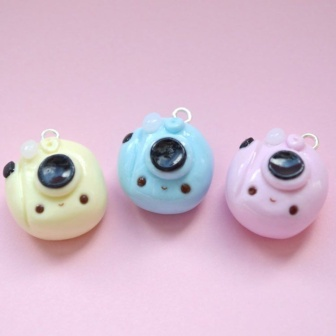Can you describe the overall aesthetic of this image? The overall aesthetic of the image is cute and whimsical, characterized by soft pastel hues that create a soothing and harmonious visual experience. The charms' round faces, petite size, and innocent expressions contribute to a sense of playfulness and delight. The pink background complements the pastel colors of the charms, enhancing the image's overall gentle and charming vibe. What do you think these cute bird-shaped charms could be used for? These bird-shaped charms could have a variety of uses. They might be used as keychains to add a touch of cuteness to one's keys, or as decorative elements on bags and backpacks. Given their charming design, they could also serve as delightful additions to a nursery mobile, a whimsical phone accessory, or even as unique pieces of jewelry, such as necklaces or bracelets. The loops on top make them ideal for hanging, offering a range of possibilities for personalizing one's space or belongings. 